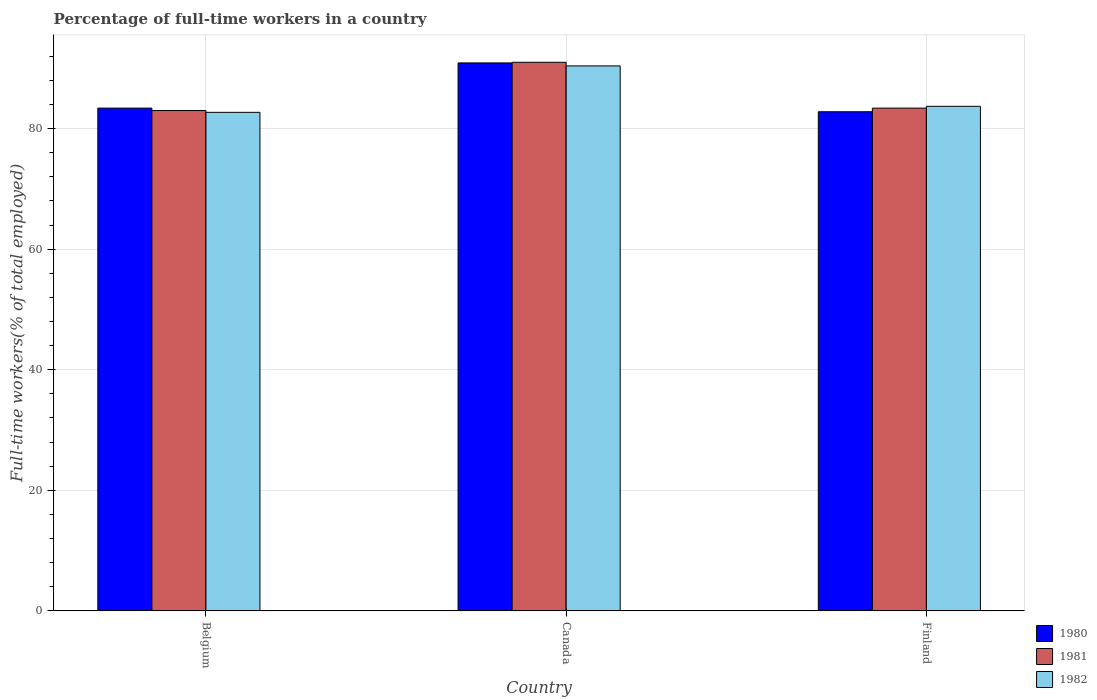How many different coloured bars are there?
Offer a terse response. 3. How many groups of bars are there?
Your answer should be very brief. 3. Are the number of bars per tick equal to the number of legend labels?
Ensure brevity in your answer.  Yes. What is the percentage of full-time workers in 1981 in Finland?
Your response must be concise. 83.4. Across all countries, what is the maximum percentage of full-time workers in 1981?
Offer a very short reply. 91. Across all countries, what is the minimum percentage of full-time workers in 1980?
Your answer should be very brief. 82.8. In which country was the percentage of full-time workers in 1982 maximum?
Keep it short and to the point. Canada. What is the total percentage of full-time workers in 1980 in the graph?
Your response must be concise. 257.1. What is the difference between the percentage of full-time workers in 1981 in Canada and the percentage of full-time workers in 1982 in Belgium?
Provide a short and direct response. 8.3. What is the average percentage of full-time workers in 1981 per country?
Your answer should be very brief. 85.8. What is the difference between the percentage of full-time workers of/in 1980 and percentage of full-time workers of/in 1982 in Canada?
Your response must be concise. 0.5. What is the ratio of the percentage of full-time workers in 1982 in Belgium to that in Canada?
Provide a succinct answer. 0.91. Is the percentage of full-time workers in 1982 in Canada less than that in Finland?
Offer a very short reply. No. Is the difference between the percentage of full-time workers in 1980 in Belgium and Finland greater than the difference between the percentage of full-time workers in 1982 in Belgium and Finland?
Your response must be concise. Yes. What is the difference between the highest and the second highest percentage of full-time workers in 1981?
Your answer should be very brief. -0.4. Is the sum of the percentage of full-time workers in 1980 in Belgium and Canada greater than the maximum percentage of full-time workers in 1982 across all countries?
Your response must be concise. Yes. What does the 3rd bar from the right in Finland represents?
Your answer should be very brief. 1980. Is it the case that in every country, the sum of the percentage of full-time workers in 1981 and percentage of full-time workers in 1980 is greater than the percentage of full-time workers in 1982?
Keep it short and to the point. Yes. How many bars are there?
Ensure brevity in your answer.  9. Are all the bars in the graph horizontal?
Provide a short and direct response. No. How many countries are there in the graph?
Offer a terse response. 3. What is the difference between two consecutive major ticks on the Y-axis?
Make the answer very short. 20. How many legend labels are there?
Provide a short and direct response. 3. How are the legend labels stacked?
Make the answer very short. Vertical. What is the title of the graph?
Provide a short and direct response. Percentage of full-time workers in a country. What is the label or title of the Y-axis?
Your response must be concise. Full-time workers(% of total employed). What is the Full-time workers(% of total employed) in 1980 in Belgium?
Your answer should be very brief. 83.4. What is the Full-time workers(% of total employed) of 1981 in Belgium?
Your answer should be compact. 83. What is the Full-time workers(% of total employed) in 1982 in Belgium?
Make the answer very short. 82.7. What is the Full-time workers(% of total employed) of 1980 in Canada?
Your answer should be compact. 90.9. What is the Full-time workers(% of total employed) of 1981 in Canada?
Offer a very short reply. 91. What is the Full-time workers(% of total employed) of 1982 in Canada?
Your answer should be very brief. 90.4. What is the Full-time workers(% of total employed) of 1980 in Finland?
Your response must be concise. 82.8. What is the Full-time workers(% of total employed) in 1981 in Finland?
Give a very brief answer. 83.4. What is the Full-time workers(% of total employed) in 1982 in Finland?
Your answer should be very brief. 83.7. Across all countries, what is the maximum Full-time workers(% of total employed) of 1980?
Provide a succinct answer. 90.9. Across all countries, what is the maximum Full-time workers(% of total employed) of 1981?
Offer a very short reply. 91. Across all countries, what is the maximum Full-time workers(% of total employed) of 1982?
Your answer should be compact. 90.4. Across all countries, what is the minimum Full-time workers(% of total employed) of 1980?
Your response must be concise. 82.8. Across all countries, what is the minimum Full-time workers(% of total employed) of 1981?
Ensure brevity in your answer.  83. Across all countries, what is the minimum Full-time workers(% of total employed) in 1982?
Keep it short and to the point. 82.7. What is the total Full-time workers(% of total employed) of 1980 in the graph?
Your answer should be very brief. 257.1. What is the total Full-time workers(% of total employed) in 1981 in the graph?
Provide a succinct answer. 257.4. What is the total Full-time workers(% of total employed) in 1982 in the graph?
Provide a succinct answer. 256.8. What is the difference between the Full-time workers(% of total employed) in 1980 in Belgium and that in Canada?
Make the answer very short. -7.5. What is the difference between the Full-time workers(% of total employed) of 1980 in Belgium and that in Finland?
Provide a short and direct response. 0.6. What is the difference between the Full-time workers(% of total employed) in 1982 in Belgium and that in Finland?
Your answer should be compact. -1. What is the difference between the Full-time workers(% of total employed) of 1980 in Canada and that in Finland?
Make the answer very short. 8.1. What is the difference between the Full-time workers(% of total employed) of 1981 in Canada and that in Finland?
Ensure brevity in your answer.  7.6. What is the difference between the Full-time workers(% of total employed) of 1982 in Canada and that in Finland?
Offer a terse response. 6.7. What is the difference between the Full-time workers(% of total employed) of 1980 in Belgium and the Full-time workers(% of total employed) of 1982 in Canada?
Your answer should be compact. -7. What is the difference between the Full-time workers(% of total employed) of 1981 in Belgium and the Full-time workers(% of total employed) of 1982 in Canada?
Ensure brevity in your answer.  -7.4. What is the difference between the Full-time workers(% of total employed) in 1980 in Belgium and the Full-time workers(% of total employed) in 1982 in Finland?
Your answer should be compact. -0.3. What is the difference between the Full-time workers(% of total employed) in 1981 in Belgium and the Full-time workers(% of total employed) in 1982 in Finland?
Ensure brevity in your answer.  -0.7. What is the difference between the Full-time workers(% of total employed) of 1980 in Canada and the Full-time workers(% of total employed) of 1982 in Finland?
Offer a very short reply. 7.2. What is the difference between the Full-time workers(% of total employed) in 1981 in Canada and the Full-time workers(% of total employed) in 1982 in Finland?
Give a very brief answer. 7.3. What is the average Full-time workers(% of total employed) of 1980 per country?
Your response must be concise. 85.7. What is the average Full-time workers(% of total employed) in 1981 per country?
Offer a very short reply. 85.8. What is the average Full-time workers(% of total employed) of 1982 per country?
Your response must be concise. 85.6. What is the difference between the Full-time workers(% of total employed) of 1980 and Full-time workers(% of total employed) of 1981 in Belgium?
Your answer should be very brief. 0.4. What is the difference between the Full-time workers(% of total employed) of 1980 and Full-time workers(% of total employed) of 1982 in Belgium?
Ensure brevity in your answer.  0.7. What is the difference between the Full-time workers(% of total employed) in 1980 and Full-time workers(% of total employed) in 1981 in Canada?
Your answer should be compact. -0.1. What is the ratio of the Full-time workers(% of total employed) in 1980 in Belgium to that in Canada?
Make the answer very short. 0.92. What is the ratio of the Full-time workers(% of total employed) of 1981 in Belgium to that in Canada?
Offer a terse response. 0.91. What is the ratio of the Full-time workers(% of total employed) of 1982 in Belgium to that in Canada?
Your response must be concise. 0.91. What is the ratio of the Full-time workers(% of total employed) in 1980 in Belgium to that in Finland?
Your answer should be compact. 1.01. What is the ratio of the Full-time workers(% of total employed) in 1981 in Belgium to that in Finland?
Your answer should be compact. 1. What is the ratio of the Full-time workers(% of total employed) of 1982 in Belgium to that in Finland?
Offer a terse response. 0.99. What is the ratio of the Full-time workers(% of total employed) of 1980 in Canada to that in Finland?
Offer a terse response. 1.1. What is the ratio of the Full-time workers(% of total employed) of 1981 in Canada to that in Finland?
Give a very brief answer. 1.09. What is the difference between the highest and the second highest Full-time workers(% of total employed) of 1982?
Offer a terse response. 6.7. What is the difference between the highest and the lowest Full-time workers(% of total employed) of 1982?
Keep it short and to the point. 7.7. 